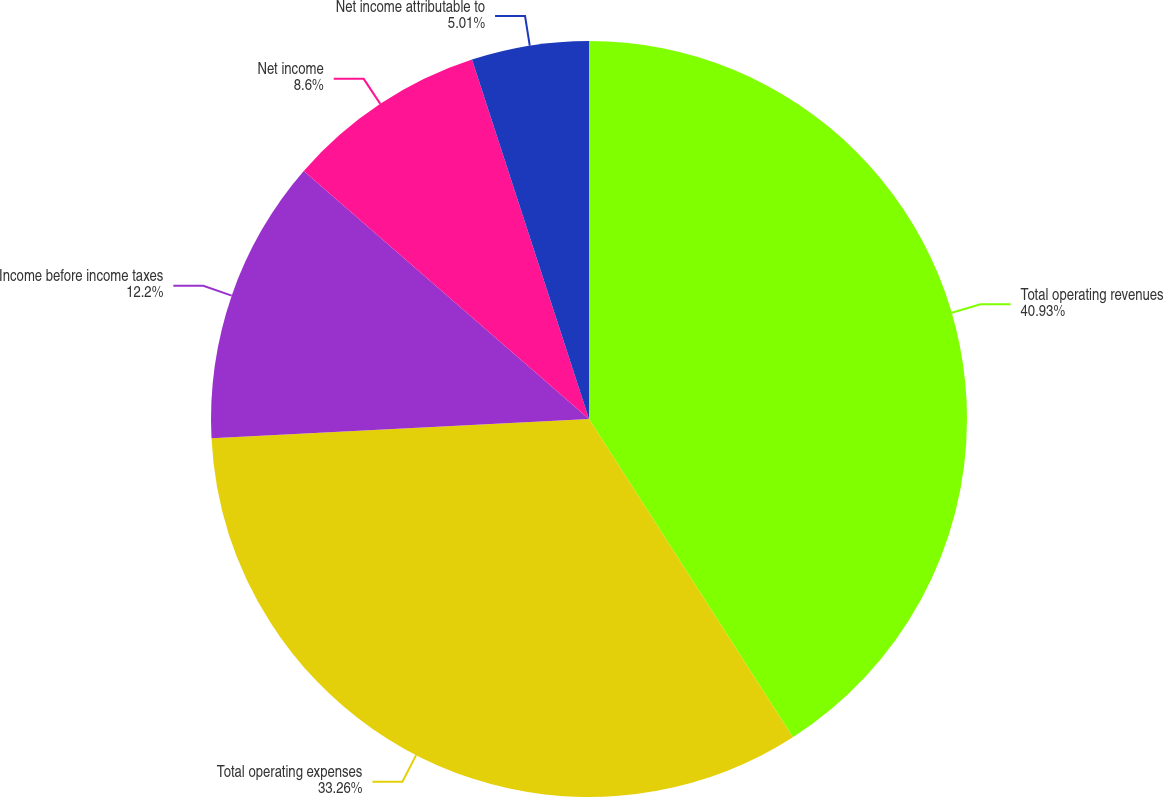Convert chart. <chart><loc_0><loc_0><loc_500><loc_500><pie_chart><fcel>Total operating revenues<fcel>Total operating expenses<fcel>Income before income taxes<fcel>Net income<fcel>Net income attributable to<nl><fcel>40.93%<fcel>33.26%<fcel>12.2%<fcel>8.6%<fcel>5.01%<nl></chart> 